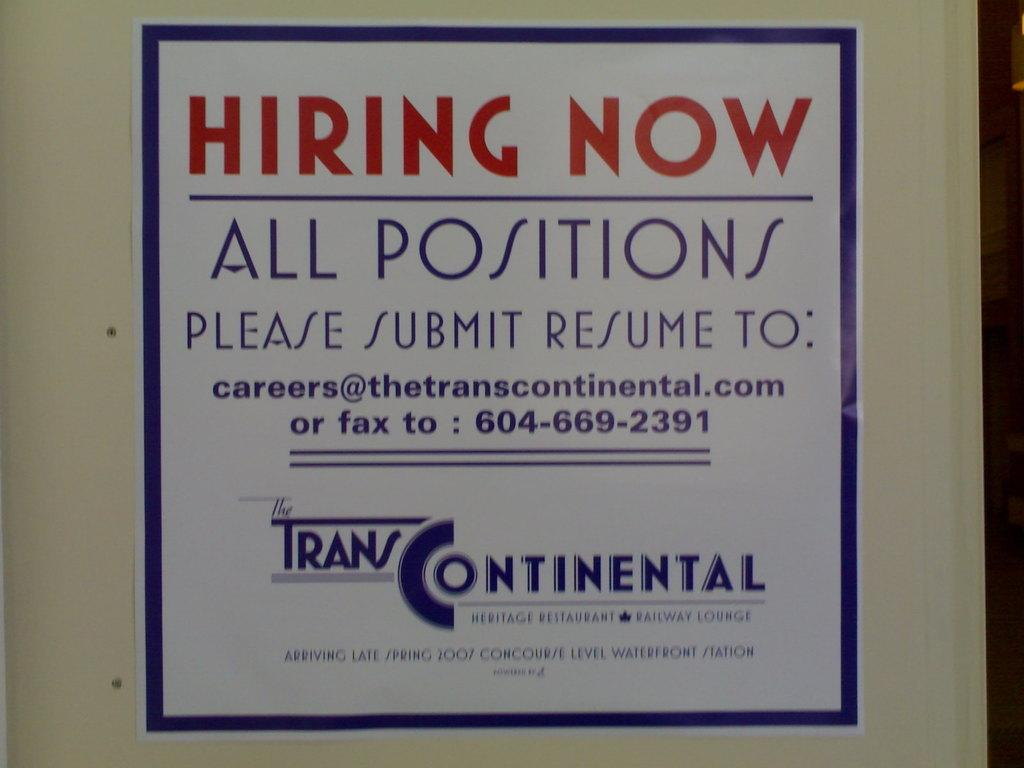<image>
Write a terse but informative summary of the picture. An advertisement for Trans Continental that they are hiring all positions. 